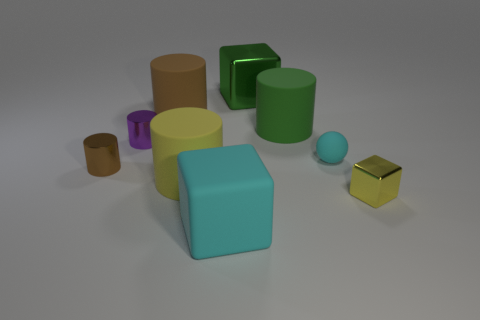What shape is the small brown metal thing that is to the left of the large cyan rubber cube? cylinder 